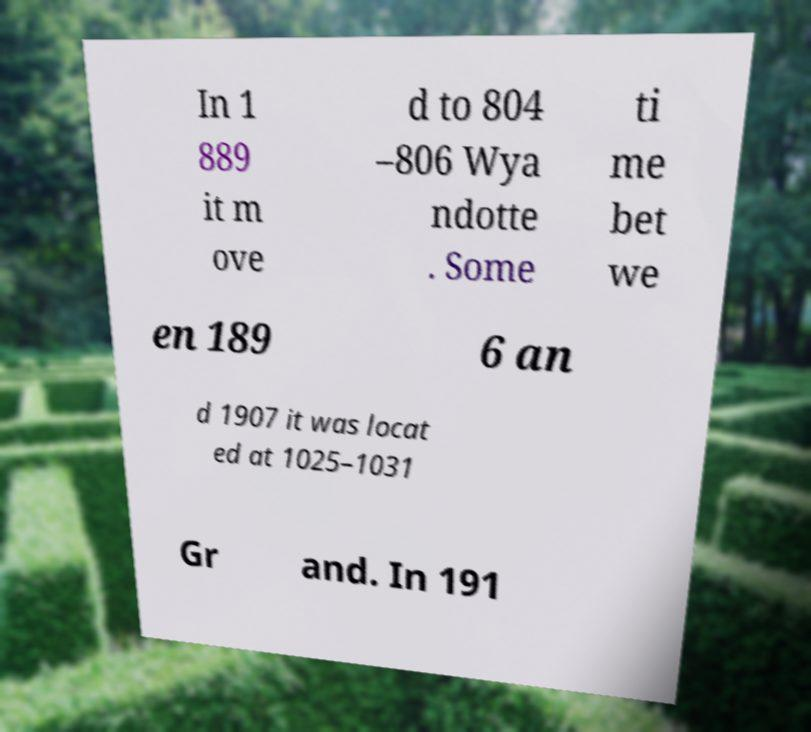Please read and relay the text visible in this image. What does it say? In 1 889 it m ove d to 804 –806 Wya ndotte . Some ti me bet we en 189 6 an d 1907 it was locat ed at 1025–1031 Gr and. In 191 